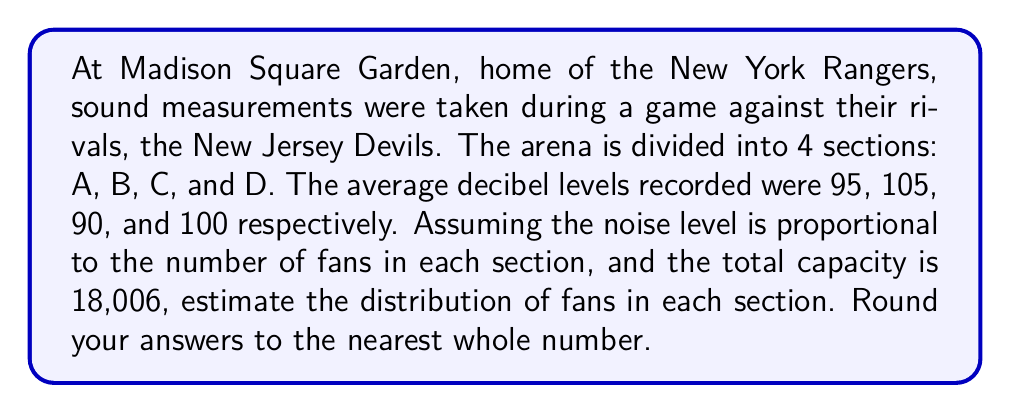Teach me how to tackle this problem. Let's approach this step-by-step:

1) First, we need to calculate the total of the decibel measurements:
   $95 + 105 + 90 + 100 = 390$ dB

2) Now, we can calculate the proportion of fans in each section:

   Section A: $\frac{95}{390} = 0.2436$
   Section B: $\frac{105}{390} = 0.2692$
   Section C: $\frac{90}{390} = 0.2308$
   Section D: $\frac{100}{390} = 0.2564$

3) To get the number of fans in each section, we multiply these proportions by the total capacity:

   Section A: $0.2436 \times 18,006 = 4,386.26$
   Section B: $0.2692 \times 18,006 = 4,849.22$
   Section C: $0.2308 \times 18,006 = 4,155.78$
   Section D: $0.2564 \times 18,006 = 4,614.74$

4) Rounding to the nearest whole number:

   Section A: 4,386
   Section B: 4,849
   Section C: 4,156
   Section D: 4,615
Answer: A: 4,386; B: 4,849; C: 4,156; D: 4,615 